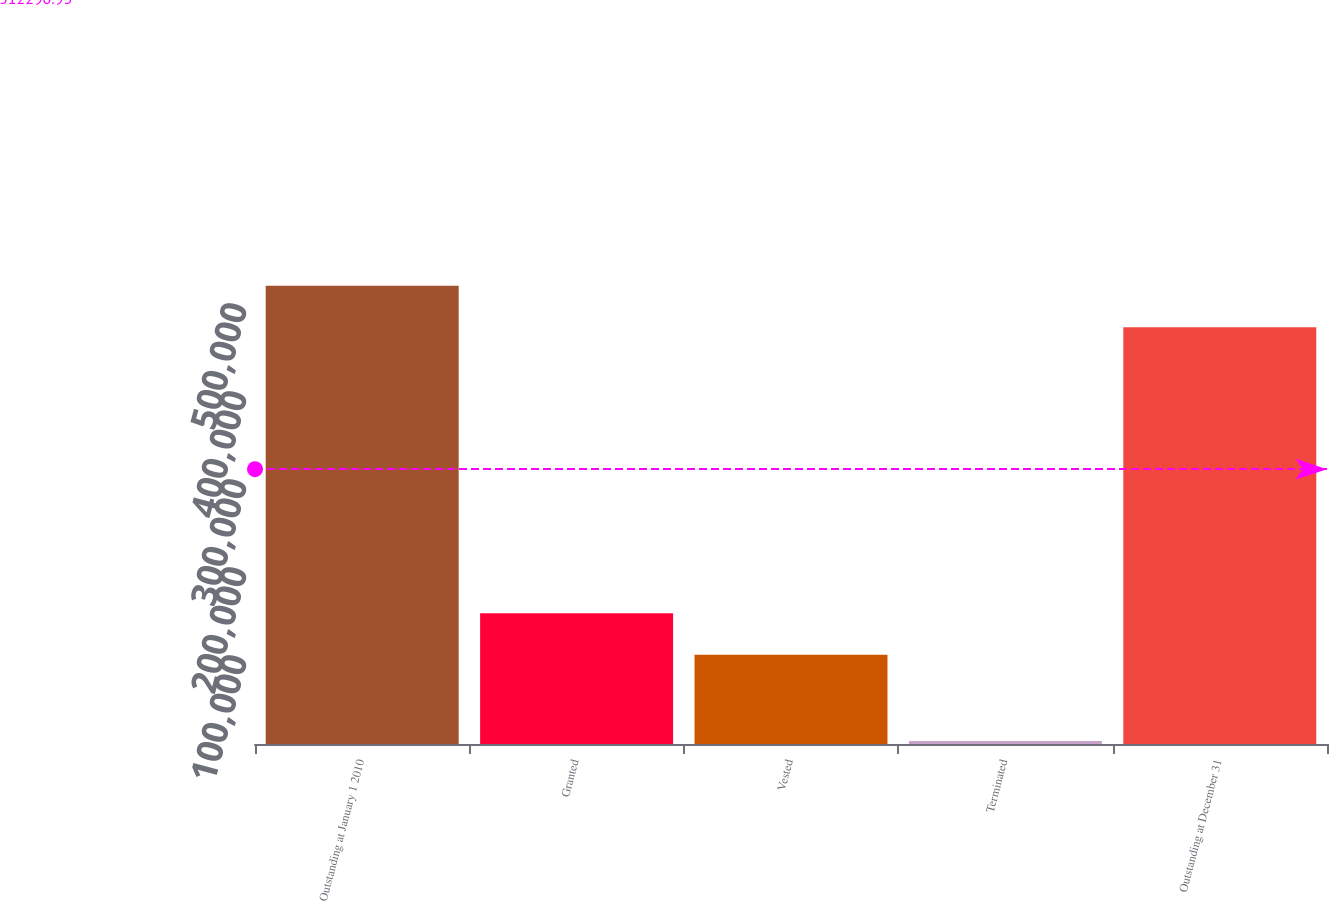Convert chart to OTSL. <chart><loc_0><loc_0><loc_500><loc_500><bar_chart><fcel>Outstanding at January 1 2010<fcel>Granted<fcel>Vested<fcel>Terminated<fcel>Outstanding at December 31<nl><fcel>520734<fcel>148696<fcel>101400<fcel>3278<fcel>473438<nl></chart> 